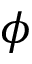Convert formula to latex. <formula><loc_0><loc_0><loc_500><loc_500>\phi</formula> 